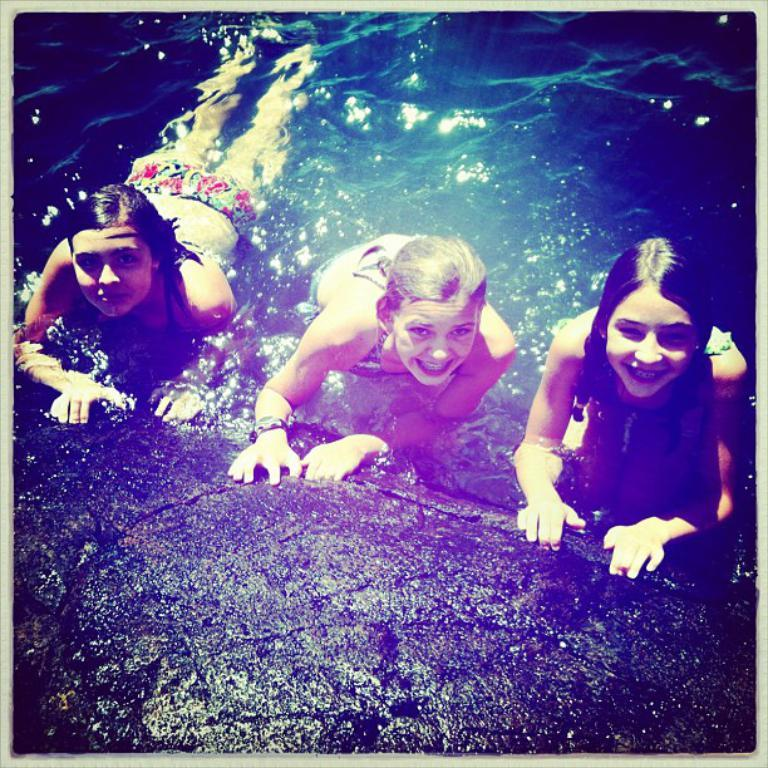How many people are in the image? There are three girls in the image. What is the facial expression of the girls? The girls are smiling. What can be seen at the bottom of the image? There is water visible at the bottom of the image. What rule do the girls follow when sorting the expansion cards in the image? There are no expansion cards or rules mentioned in the image; it only shows three girls smiling. 